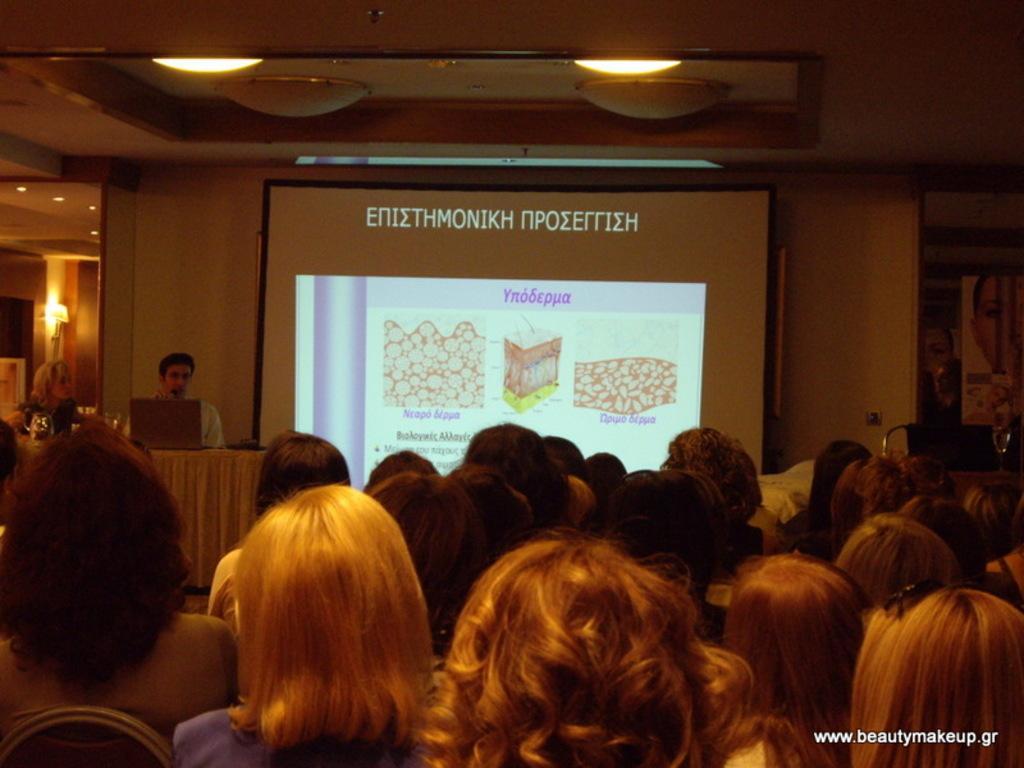How would you summarize this image in a sentence or two? This picture is taken inside the conference hall. In this image, we can see a group of people sitting on the chair. On the left side, we can see two people man and woman are sitting on the chair in front of the table, on the table, we can see a white colored cloth, laptop and some objects. In the background, we can see a screen, on the screen, we can see some pictures and text written on it. On the right side, we can see a door. On the left side, we can see few lights. At the top, we can see a roof with few lights. 